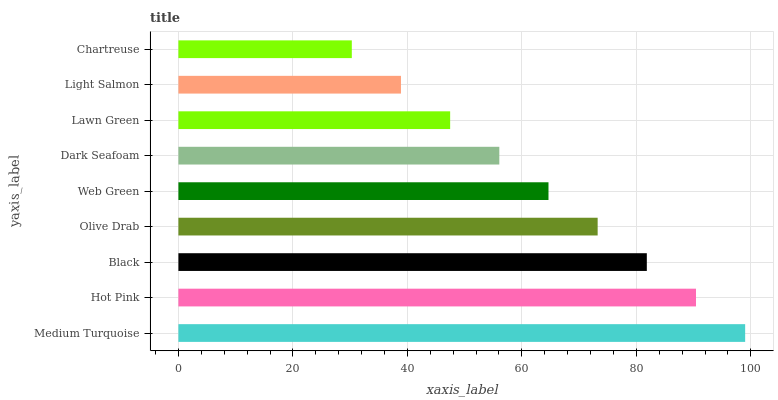Is Chartreuse the minimum?
Answer yes or no. Yes. Is Medium Turquoise the maximum?
Answer yes or no. Yes. Is Hot Pink the minimum?
Answer yes or no. No. Is Hot Pink the maximum?
Answer yes or no. No. Is Medium Turquoise greater than Hot Pink?
Answer yes or no. Yes. Is Hot Pink less than Medium Turquoise?
Answer yes or no. Yes. Is Hot Pink greater than Medium Turquoise?
Answer yes or no. No. Is Medium Turquoise less than Hot Pink?
Answer yes or no. No. Is Web Green the high median?
Answer yes or no. Yes. Is Web Green the low median?
Answer yes or no. Yes. Is Olive Drab the high median?
Answer yes or no. No. Is Medium Turquoise the low median?
Answer yes or no. No. 